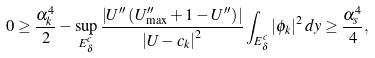<formula> <loc_0><loc_0><loc_500><loc_500>0 \geq \frac { \alpha _ { k } ^ { 4 } } { 2 } - \sup _ { E _ { \delta } ^ { c } } \frac { \left | U ^ { \prime \prime } \left ( U _ { \max } ^ { \prime \prime } + 1 - U ^ { \prime \prime } \right ) \right | } { \left | U - c _ { k } \right | ^ { 2 } } \int _ { E _ { \delta } ^ { c } } \left | \phi _ { k } \right | ^ { 2 } d y \geq \frac { \alpha _ { s } ^ { 4 } } { 4 } ,</formula> 